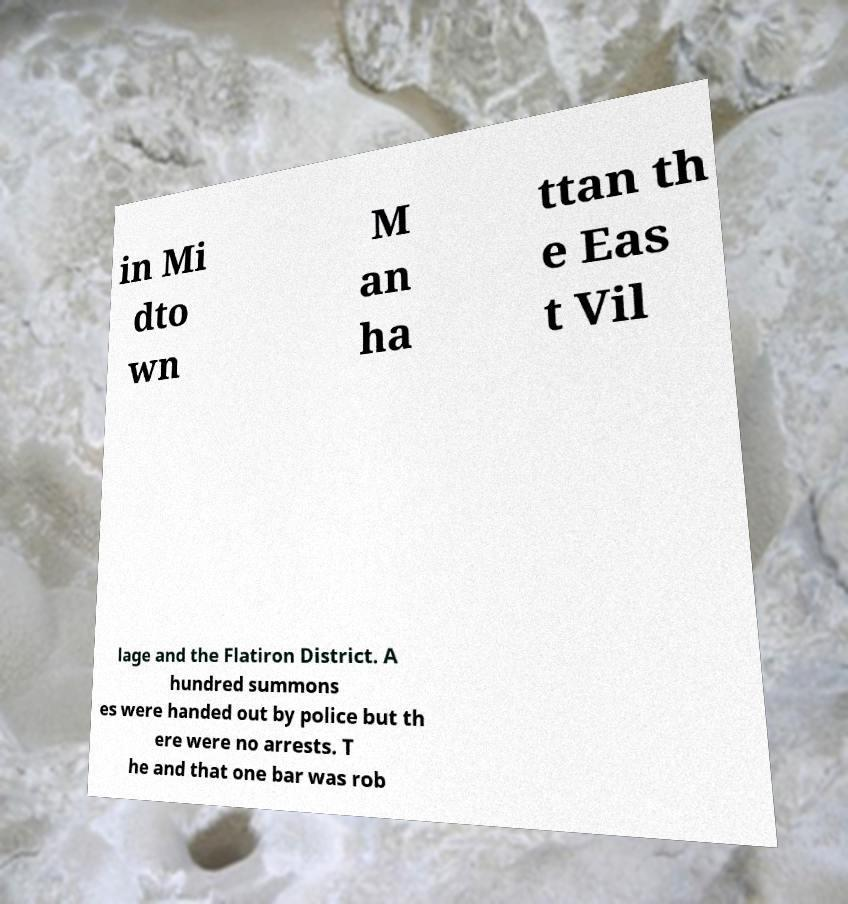Please read and relay the text visible in this image. What does it say? in Mi dto wn M an ha ttan th e Eas t Vil lage and the Flatiron District. A hundred summons es were handed out by police but th ere were no arrests. T he and that one bar was rob 